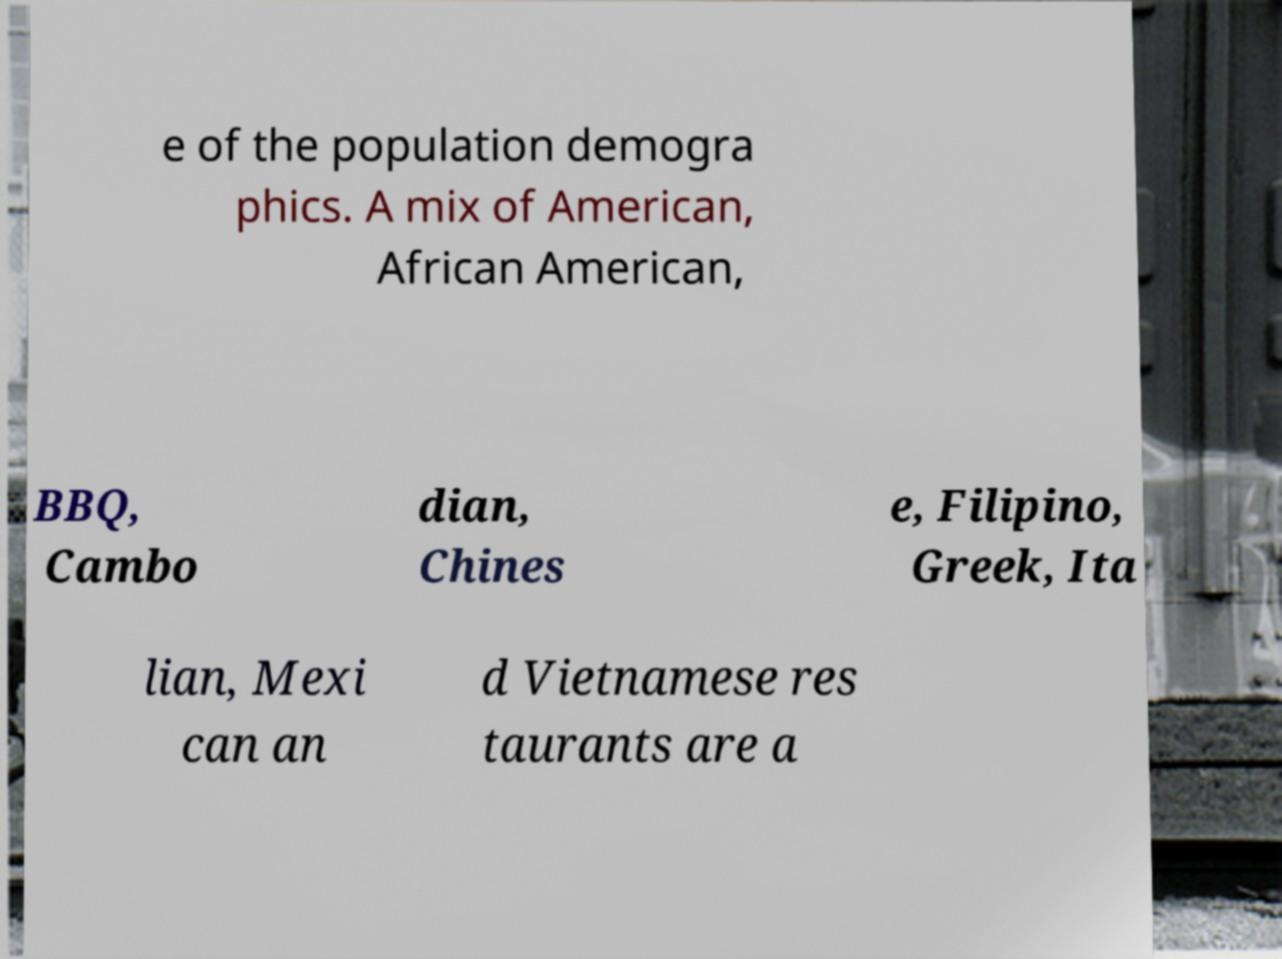There's text embedded in this image that I need extracted. Can you transcribe it verbatim? e of the population demogra phics. A mix of American, African American, BBQ, Cambo dian, Chines e, Filipino, Greek, Ita lian, Mexi can an d Vietnamese res taurants are a 